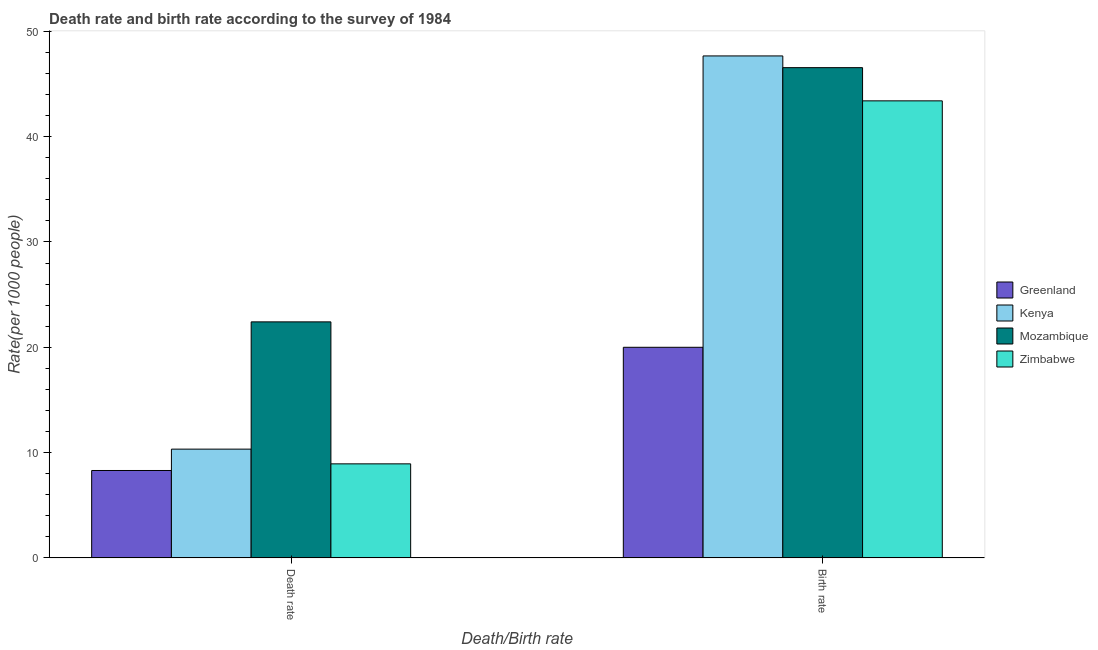How many different coloured bars are there?
Your answer should be very brief. 4. How many bars are there on the 2nd tick from the right?
Provide a succinct answer. 4. What is the label of the 2nd group of bars from the left?
Your response must be concise. Birth rate. What is the birth rate in Zimbabwe?
Your response must be concise. 43.4. Across all countries, what is the maximum death rate?
Your answer should be compact. 22.41. In which country was the death rate maximum?
Provide a succinct answer. Mozambique. In which country was the birth rate minimum?
Keep it short and to the point. Greenland. What is the total death rate in the graph?
Your answer should be compact. 49.98. What is the difference between the birth rate in Mozambique and that in Greenland?
Provide a succinct answer. 26.56. What is the difference between the birth rate in Zimbabwe and the death rate in Kenya?
Your answer should be very brief. 33.08. What is the average birth rate per country?
Ensure brevity in your answer.  39.41. What is the difference between the death rate and birth rate in Mozambique?
Provide a succinct answer. -24.14. In how many countries, is the birth rate greater than 8 ?
Offer a very short reply. 4. What is the ratio of the birth rate in Zimbabwe to that in Kenya?
Your response must be concise. 0.91. Is the death rate in Kenya less than that in Mozambique?
Provide a short and direct response. Yes. What does the 1st bar from the left in Death rate represents?
Your answer should be very brief. Greenland. What does the 1st bar from the right in Birth rate represents?
Offer a terse response. Zimbabwe. How many bars are there?
Ensure brevity in your answer.  8. Are all the bars in the graph horizontal?
Provide a succinct answer. No. How many countries are there in the graph?
Offer a very short reply. 4. What is the difference between two consecutive major ticks on the Y-axis?
Offer a very short reply. 10. Are the values on the major ticks of Y-axis written in scientific E-notation?
Make the answer very short. No. Does the graph contain grids?
Keep it short and to the point. No. Where does the legend appear in the graph?
Your answer should be very brief. Center right. How many legend labels are there?
Give a very brief answer. 4. How are the legend labels stacked?
Offer a terse response. Vertical. What is the title of the graph?
Your answer should be compact. Death rate and birth rate according to the survey of 1984. What is the label or title of the X-axis?
Your answer should be compact. Death/Birth rate. What is the label or title of the Y-axis?
Provide a succinct answer. Rate(per 1000 people). What is the Rate(per 1000 people) in Greenland in Death rate?
Provide a short and direct response. 8.3. What is the Rate(per 1000 people) in Kenya in Death rate?
Make the answer very short. 10.33. What is the Rate(per 1000 people) of Mozambique in Death rate?
Offer a very short reply. 22.41. What is the Rate(per 1000 people) of Zimbabwe in Death rate?
Provide a short and direct response. 8.93. What is the Rate(per 1000 people) of Kenya in Birth rate?
Keep it short and to the point. 47.67. What is the Rate(per 1000 people) in Mozambique in Birth rate?
Provide a short and direct response. 46.56. What is the Rate(per 1000 people) in Zimbabwe in Birth rate?
Your answer should be compact. 43.4. Across all Death/Birth rate, what is the maximum Rate(per 1000 people) of Greenland?
Your answer should be very brief. 20. Across all Death/Birth rate, what is the maximum Rate(per 1000 people) of Kenya?
Provide a succinct answer. 47.67. Across all Death/Birth rate, what is the maximum Rate(per 1000 people) of Mozambique?
Offer a terse response. 46.56. Across all Death/Birth rate, what is the maximum Rate(per 1000 people) of Zimbabwe?
Offer a very short reply. 43.4. Across all Death/Birth rate, what is the minimum Rate(per 1000 people) of Kenya?
Ensure brevity in your answer.  10.33. Across all Death/Birth rate, what is the minimum Rate(per 1000 people) of Mozambique?
Ensure brevity in your answer.  22.41. Across all Death/Birth rate, what is the minimum Rate(per 1000 people) of Zimbabwe?
Your answer should be very brief. 8.93. What is the total Rate(per 1000 people) in Greenland in the graph?
Provide a short and direct response. 28.3. What is the total Rate(per 1000 people) in Kenya in the graph?
Give a very brief answer. 58. What is the total Rate(per 1000 people) in Mozambique in the graph?
Your answer should be compact. 68.97. What is the total Rate(per 1000 people) of Zimbabwe in the graph?
Your answer should be very brief. 52.34. What is the difference between the Rate(per 1000 people) in Kenya in Death rate and that in Birth rate?
Make the answer very short. -37.34. What is the difference between the Rate(per 1000 people) of Mozambique in Death rate and that in Birth rate?
Provide a succinct answer. -24.14. What is the difference between the Rate(per 1000 people) in Zimbabwe in Death rate and that in Birth rate?
Provide a short and direct response. -34.47. What is the difference between the Rate(per 1000 people) of Greenland in Death rate and the Rate(per 1000 people) of Kenya in Birth rate?
Give a very brief answer. -39.37. What is the difference between the Rate(per 1000 people) of Greenland in Death rate and the Rate(per 1000 people) of Mozambique in Birth rate?
Ensure brevity in your answer.  -38.26. What is the difference between the Rate(per 1000 people) of Greenland in Death rate and the Rate(per 1000 people) of Zimbabwe in Birth rate?
Your response must be concise. -35.1. What is the difference between the Rate(per 1000 people) in Kenya in Death rate and the Rate(per 1000 people) in Mozambique in Birth rate?
Make the answer very short. -36.23. What is the difference between the Rate(per 1000 people) in Kenya in Death rate and the Rate(per 1000 people) in Zimbabwe in Birth rate?
Keep it short and to the point. -33.08. What is the difference between the Rate(per 1000 people) of Mozambique in Death rate and the Rate(per 1000 people) of Zimbabwe in Birth rate?
Provide a succinct answer. -20.99. What is the average Rate(per 1000 people) of Greenland per Death/Birth rate?
Offer a very short reply. 14.15. What is the average Rate(per 1000 people) in Kenya per Death/Birth rate?
Provide a succinct answer. 29. What is the average Rate(per 1000 people) of Mozambique per Death/Birth rate?
Your response must be concise. 34.49. What is the average Rate(per 1000 people) in Zimbabwe per Death/Birth rate?
Make the answer very short. 26.17. What is the difference between the Rate(per 1000 people) of Greenland and Rate(per 1000 people) of Kenya in Death rate?
Ensure brevity in your answer.  -2.03. What is the difference between the Rate(per 1000 people) of Greenland and Rate(per 1000 people) of Mozambique in Death rate?
Your answer should be compact. -14.12. What is the difference between the Rate(per 1000 people) of Greenland and Rate(per 1000 people) of Zimbabwe in Death rate?
Your response must be concise. -0.63. What is the difference between the Rate(per 1000 people) in Kenya and Rate(per 1000 people) in Mozambique in Death rate?
Ensure brevity in your answer.  -12.09. What is the difference between the Rate(per 1000 people) of Kenya and Rate(per 1000 people) of Zimbabwe in Death rate?
Your answer should be compact. 1.4. What is the difference between the Rate(per 1000 people) of Mozambique and Rate(per 1000 people) of Zimbabwe in Death rate?
Keep it short and to the point. 13.48. What is the difference between the Rate(per 1000 people) of Greenland and Rate(per 1000 people) of Kenya in Birth rate?
Your answer should be compact. -27.67. What is the difference between the Rate(per 1000 people) of Greenland and Rate(per 1000 people) of Mozambique in Birth rate?
Your answer should be compact. -26.56. What is the difference between the Rate(per 1000 people) of Greenland and Rate(per 1000 people) of Zimbabwe in Birth rate?
Your answer should be compact. -23.4. What is the difference between the Rate(per 1000 people) in Kenya and Rate(per 1000 people) in Mozambique in Birth rate?
Offer a very short reply. 1.11. What is the difference between the Rate(per 1000 people) of Kenya and Rate(per 1000 people) of Zimbabwe in Birth rate?
Offer a very short reply. 4.27. What is the difference between the Rate(per 1000 people) of Mozambique and Rate(per 1000 people) of Zimbabwe in Birth rate?
Provide a succinct answer. 3.15. What is the ratio of the Rate(per 1000 people) in Greenland in Death rate to that in Birth rate?
Your answer should be very brief. 0.41. What is the ratio of the Rate(per 1000 people) of Kenya in Death rate to that in Birth rate?
Your response must be concise. 0.22. What is the ratio of the Rate(per 1000 people) of Mozambique in Death rate to that in Birth rate?
Your answer should be compact. 0.48. What is the ratio of the Rate(per 1000 people) in Zimbabwe in Death rate to that in Birth rate?
Offer a terse response. 0.21. What is the difference between the highest and the second highest Rate(per 1000 people) in Greenland?
Ensure brevity in your answer.  11.7. What is the difference between the highest and the second highest Rate(per 1000 people) in Kenya?
Make the answer very short. 37.34. What is the difference between the highest and the second highest Rate(per 1000 people) in Mozambique?
Your response must be concise. 24.14. What is the difference between the highest and the second highest Rate(per 1000 people) in Zimbabwe?
Keep it short and to the point. 34.47. What is the difference between the highest and the lowest Rate(per 1000 people) in Kenya?
Offer a very short reply. 37.34. What is the difference between the highest and the lowest Rate(per 1000 people) in Mozambique?
Provide a succinct answer. 24.14. What is the difference between the highest and the lowest Rate(per 1000 people) of Zimbabwe?
Offer a terse response. 34.47. 